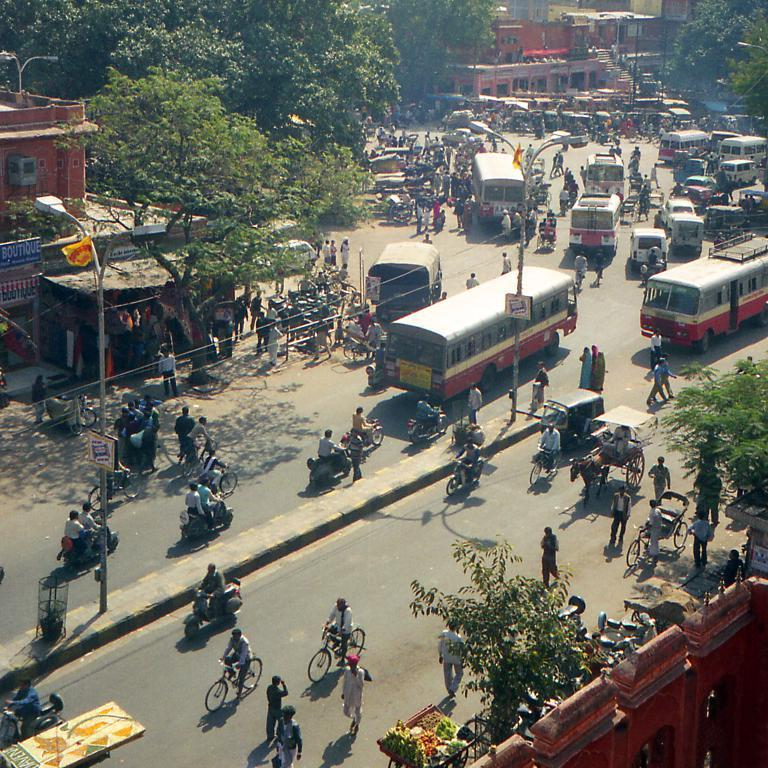<image>
Describe the image concisely. A blue sign for a boutique can be seen on the left side of the street. 